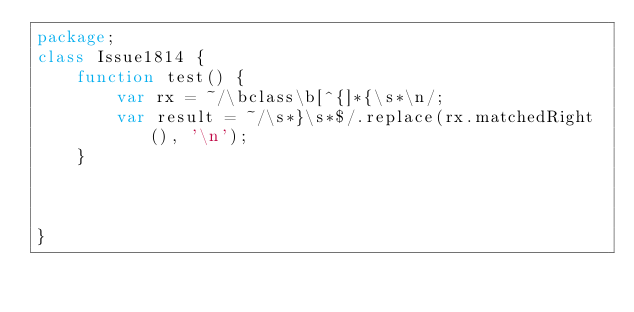Convert code to text. <code><loc_0><loc_0><loc_500><loc_500><_Haxe_>package;
class Issue1814 {
	function test() {
		var rx = ~/\bclass\b[^{]*{\s*\n/;
		var result = ~/\s*}\s*$/.replace(rx.matchedRight(), '\n');
	}
	
	
	
}</code> 